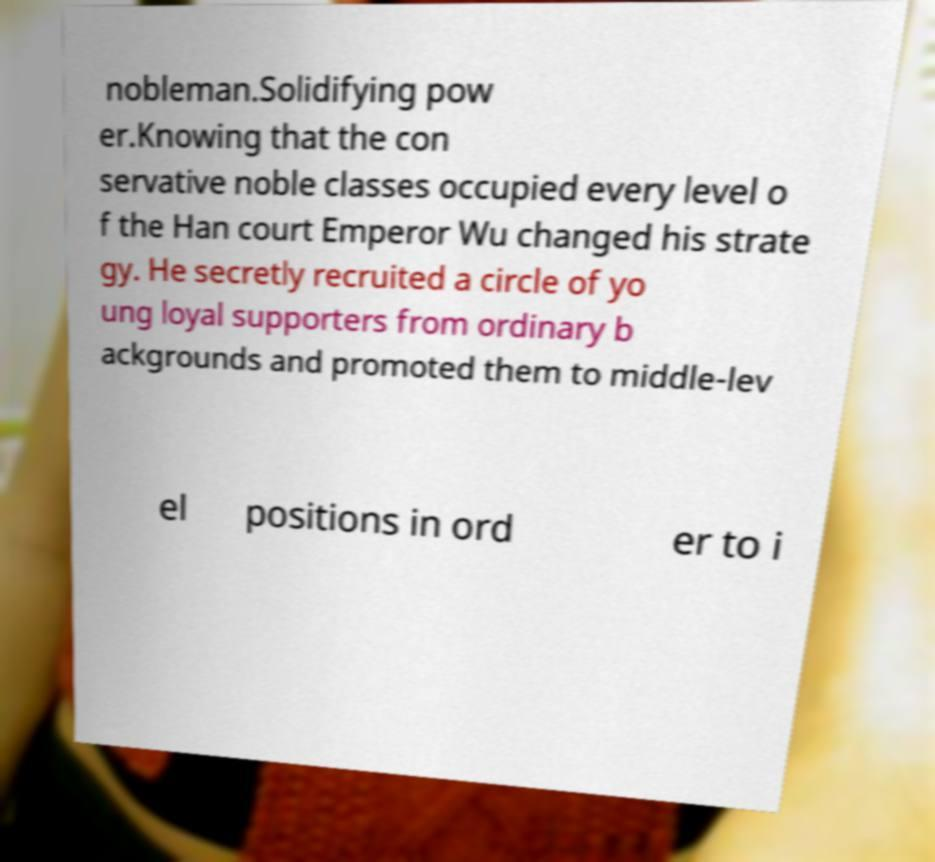I need the written content from this picture converted into text. Can you do that? nobleman.Solidifying pow er.Knowing that the con servative noble classes occupied every level o f the Han court Emperor Wu changed his strate gy. He secretly recruited a circle of yo ung loyal supporters from ordinary b ackgrounds and promoted them to middle-lev el positions in ord er to i 